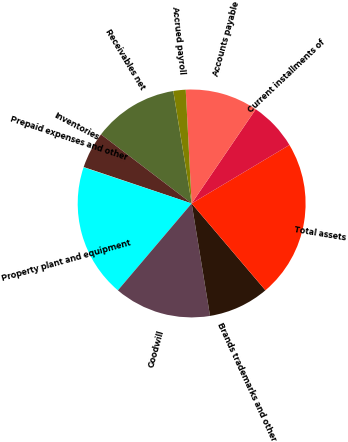Convert chart. <chart><loc_0><loc_0><loc_500><loc_500><pie_chart><fcel>Receivables net<fcel>Inventories<fcel>Prepaid expenses and other<fcel>Property plant and equipment<fcel>Goodwill<fcel>Brands trademarks and other<fcel>Total assets<fcel>Current installments of<fcel>Accounts payable<fcel>Accrued payroll<nl><fcel>12.06%<fcel>5.19%<fcel>0.04%<fcel>18.93%<fcel>13.78%<fcel>8.63%<fcel>22.37%<fcel>6.91%<fcel>10.34%<fcel>1.75%<nl></chart> 